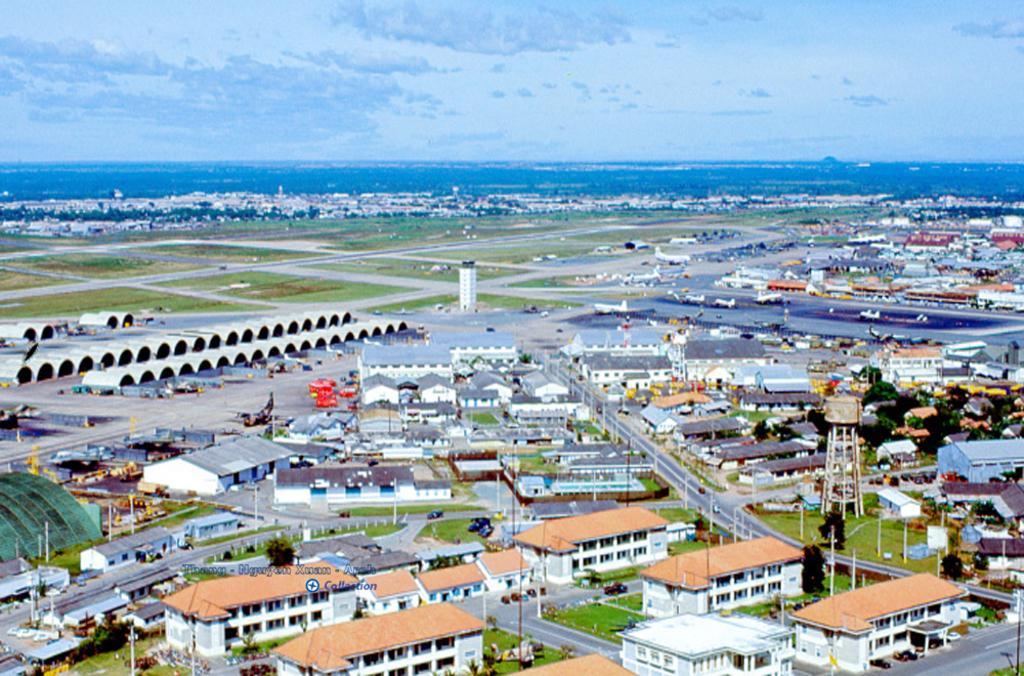Describe this image in one or two sentences. In this image we can see buildings, road, trees, vehicles, grass, poles and cloudy sky. 